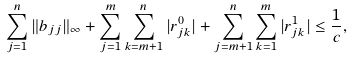<formula> <loc_0><loc_0><loc_500><loc_500>\sum _ { j = 1 } ^ { n } \| b _ { j j } \| _ { \infty } + \sum _ { j = 1 } ^ { m } \sum _ { k = m + 1 } ^ { n } | r ^ { 0 } _ { j k } | + \sum _ { j = m + 1 } ^ { n } \sum _ { k = 1 } ^ { m } | r ^ { 1 } _ { j k } | \leq \frac { 1 } { c } ,</formula> 